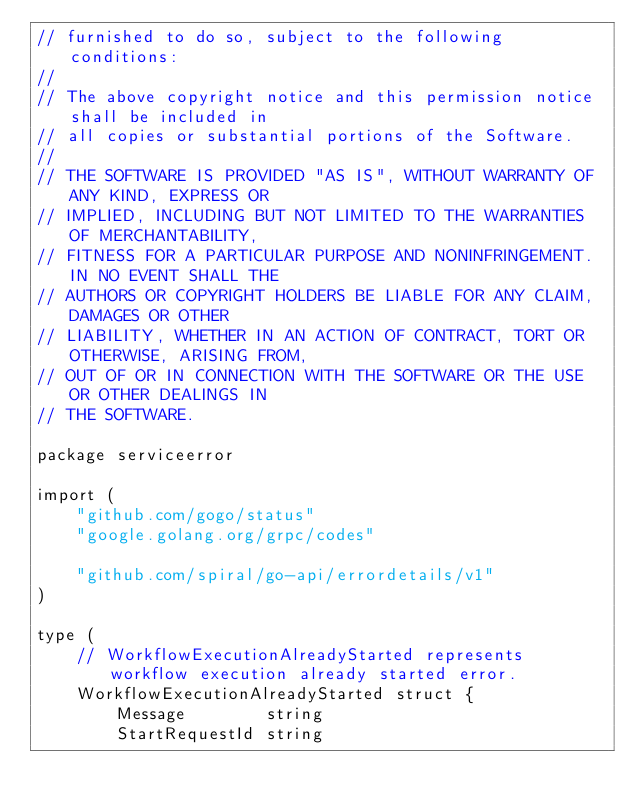Convert code to text. <code><loc_0><loc_0><loc_500><loc_500><_Go_>// furnished to do so, subject to the following conditions:
//
// The above copyright notice and this permission notice shall be included in
// all copies or substantial portions of the Software.
//
// THE SOFTWARE IS PROVIDED "AS IS", WITHOUT WARRANTY OF ANY KIND, EXPRESS OR
// IMPLIED, INCLUDING BUT NOT LIMITED TO THE WARRANTIES OF MERCHANTABILITY,
// FITNESS FOR A PARTICULAR PURPOSE AND NONINFRINGEMENT. IN NO EVENT SHALL THE
// AUTHORS OR COPYRIGHT HOLDERS BE LIABLE FOR ANY CLAIM, DAMAGES OR OTHER
// LIABILITY, WHETHER IN AN ACTION OF CONTRACT, TORT OR OTHERWISE, ARISING FROM,
// OUT OF OR IN CONNECTION WITH THE SOFTWARE OR THE USE OR OTHER DEALINGS IN
// THE SOFTWARE.

package serviceerror

import (
	"github.com/gogo/status"
	"google.golang.org/grpc/codes"

	"github.com/spiral/go-api/errordetails/v1"
)

type (
	// WorkflowExecutionAlreadyStarted represents workflow execution already started error.
	WorkflowExecutionAlreadyStarted struct {
		Message        string
		StartRequestId string</code> 